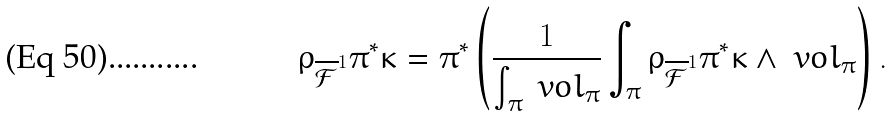<formula> <loc_0><loc_0><loc_500><loc_500>\rho _ { \overline { \mathcal { F } } ^ { 1 } } \pi ^ { * } \kappa = \pi ^ { * } \left ( \frac { 1 } { \int _ { \pi } \ v o l _ { \pi } } \int _ { \pi } \rho _ { \overline { \mathcal { F } } ^ { 1 } } \pi ^ { * } \kappa \wedge \ v o l _ { \pi } \right ) .</formula> 